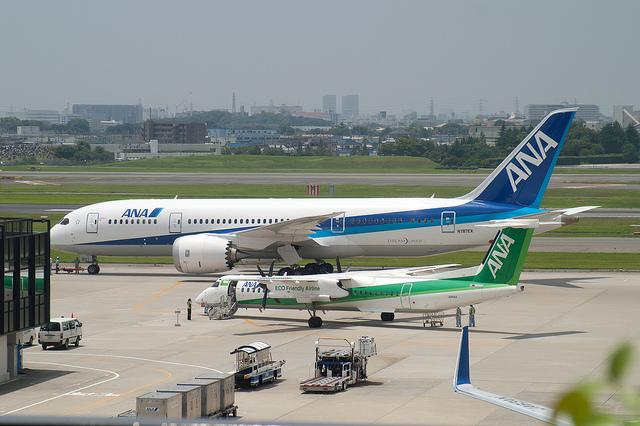Which vehicle can carry the most volume of supplies?

Choices:
A) green plane
B) blue plane
C) van
D) luggage cart blue plane 